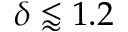<formula> <loc_0><loc_0><loc_500><loc_500>\delta \lessapprox 1 . 2</formula> 